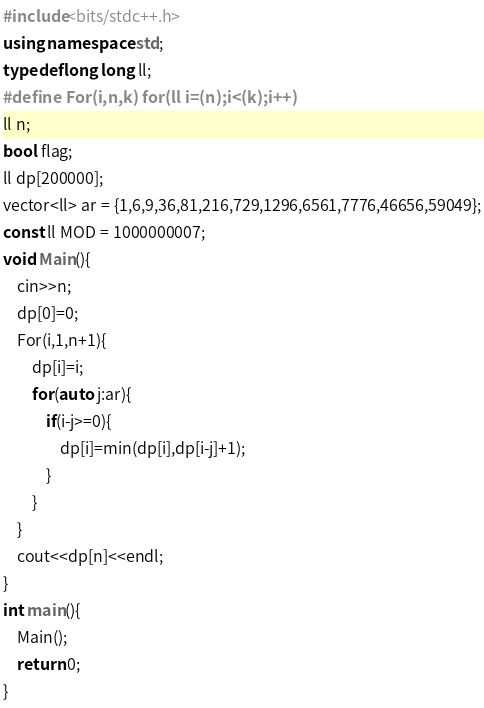<code> <loc_0><loc_0><loc_500><loc_500><_C++_>
#include<bits/stdc++.h>
using namespace std;
typedef long long ll;
#define For(i,n,k) for(ll i=(n);i<(k);i++)
ll n;
bool flag;
ll dp[200000];
vector<ll> ar = {1,6,9,36,81,216,729,1296,6561,7776,46656,59049};
const ll MOD = 1000000007;
void Main(){    
    cin>>n;
    dp[0]=0;
    For(i,1,n+1){
        dp[i]=i;
        for(auto j:ar){
            if(i-j>=0){
                dp[i]=min(dp[i],dp[i-j]+1);
            }
        }
    }
    cout<<dp[n]<<endl;
}
int main(){
    Main();
    return 0;
}
</code> 